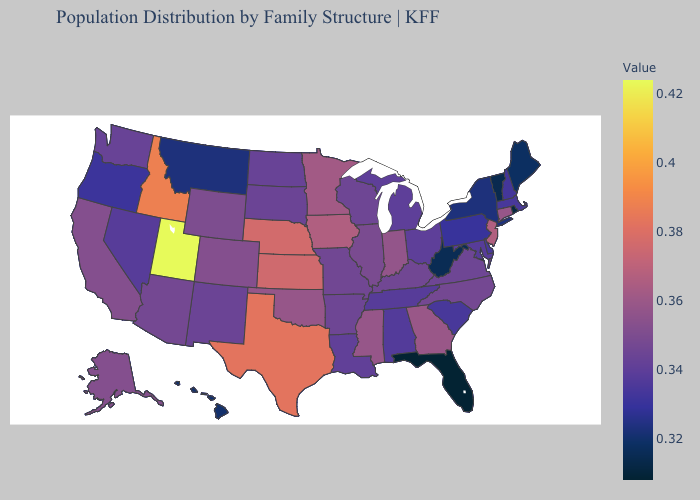Does Utah have a higher value than Oklahoma?
Short answer required. Yes. Among the states that border Arizona , which have the lowest value?
Short answer required. Nevada. Among the states that border Idaho , does Utah have the highest value?
Concise answer only. Yes. Which states hav the highest value in the Northeast?
Give a very brief answer. New Jersey. Among the states that border Michigan , which have the lowest value?
Give a very brief answer. Ohio. Does Nebraska have the highest value in the MidWest?
Keep it brief. Yes. 